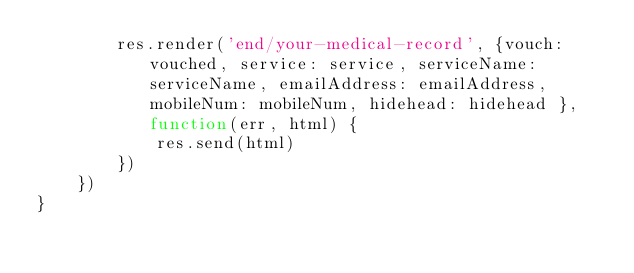Convert code to text. <code><loc_0><loc_0><loc_500><loc_500><_JavaScript_>        res.render('end/your-medical-record', {vouch: vouched, service: service, serviceName: serviceName, emailAddress: emailAddress, mobileNum: mobileNum, hidehead: hidehead }, function(err, html) {
            res.send(html)
        })
    })
}</code> 